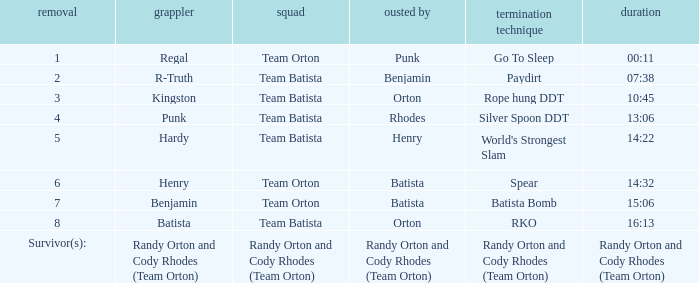What is the Elimination move listed against Regal? Go To Sleep. 